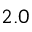<formula> <loc_0><loc_0><loc_500><loc_500>2 . 0</formula> 